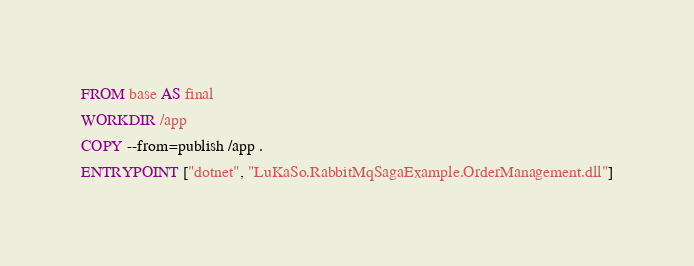Convert code to text. <code><loc_0><loc_0><loc_500><loc_500><_Dockerfile_>
FROM base AS final
WORKDIR /app
COPY --from=publish /app .
ENTRYPOINT ["dotnet", "LuKaSo.RabbitMqSagaExample.OrderManagement.dll"]</code> 